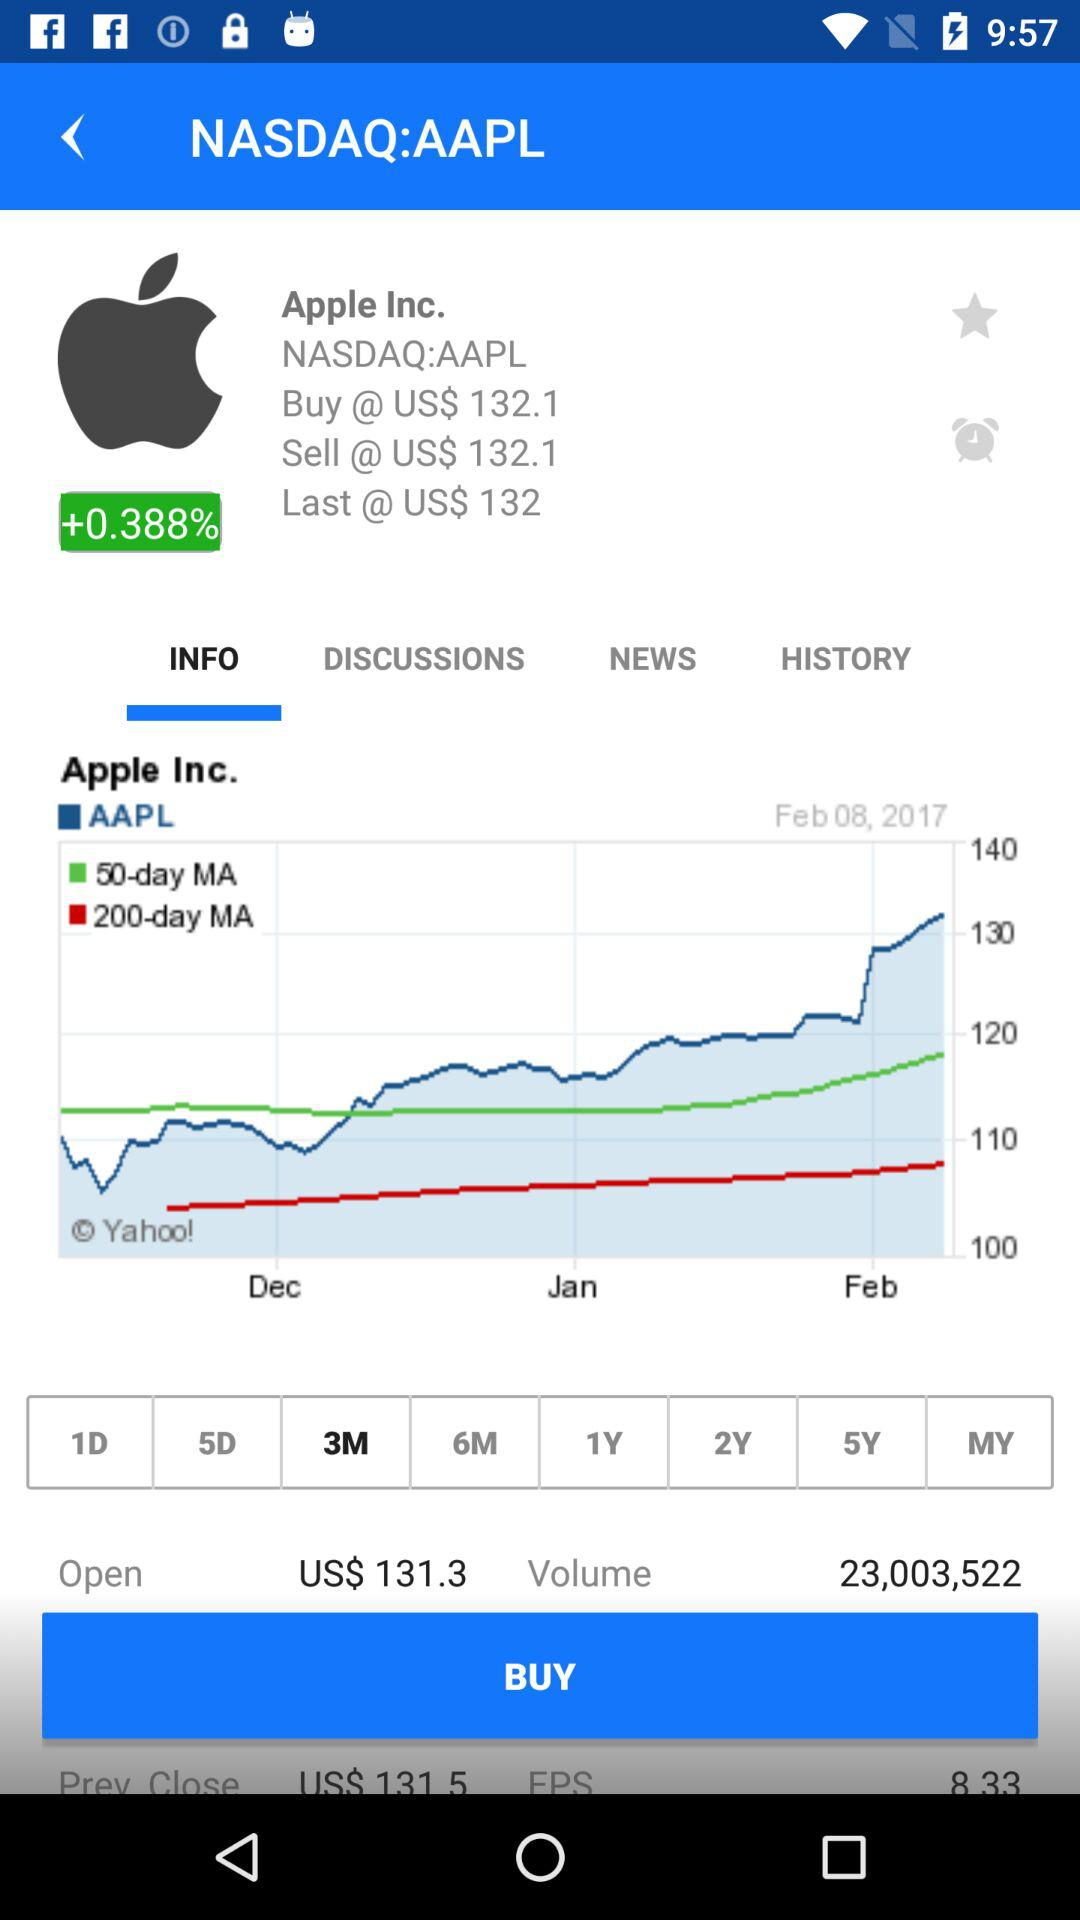What is the given date? The given date is 8 February, 2017. 